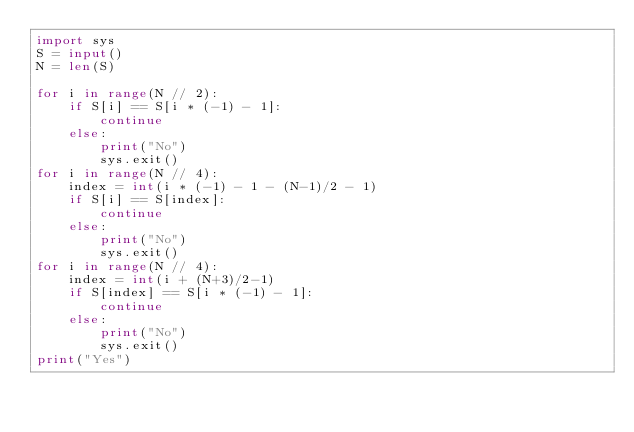<code> <loc_0><loc_0><loc_500><loc_500><_Python_>import sys
S = input()
N = len(S)

for i in range(N // 2):
    if S[i] == S[i * (-1) - 1]:
        continue
    else:
        print("No")
        sys.exit()
for i in range(N // 4):
    index = int(i * (-1) - 1 - (N-1)/2 - 1)
    if S[i] == S[index]:
        continue
    else:
        print("No")
        sys.exit()
for i in range(N // 4):
    index = int(i + (N+3)/2-1)
    if S[index] == S[i * (-1) - 1]:
        continue
    else:
        print("No")
        sys.exit()
print("Yes")
</code> 